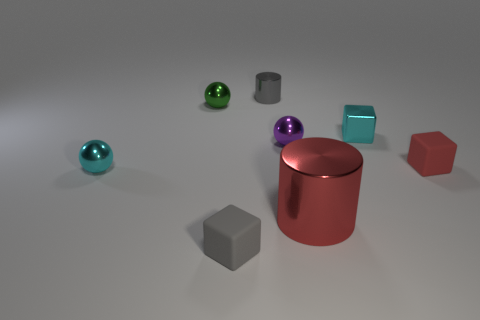What size is the cylinder that is in front of the small shiny thing that is on the right side of the small purple sphere?
Your answer should be compact. Large. There is a gray object behind the gray matte cube; does it have the same size as the big red metal thing?
Your answer should be very brief. No. Are there more green spheres on the left side of the small purple thing than small purple shiny balls in front of the tiny red block?
Make the answer very short. Yes. The thing that is on the right side of the green metallic ball and to the left of the tiny cylinder has what shape?
Keep it short and to the point. Cube. The small rubber object that is behind the tiny gray matte object has what shape?
Provide a succinct answer. Cube. What size is the red object that is right of the small cyan object right of the rubber block in front of the small red rubber thing?
Provide a short and direct response. Small. Is the shape of the large object the same as the purple object?
Your response must be concise. No. What is the size of the metal object that is to the right of the gray cube and in front of the tiny red rubber object?
Provide a short and direct response. Large. There is a small object that is the same shape as the large object; what is its material?
Offer a terse response. Metal. What material is the gray object behind the tiny cyan shiny object in front of the tiny purple ball made of?
Give a very brief answer. Metal. 